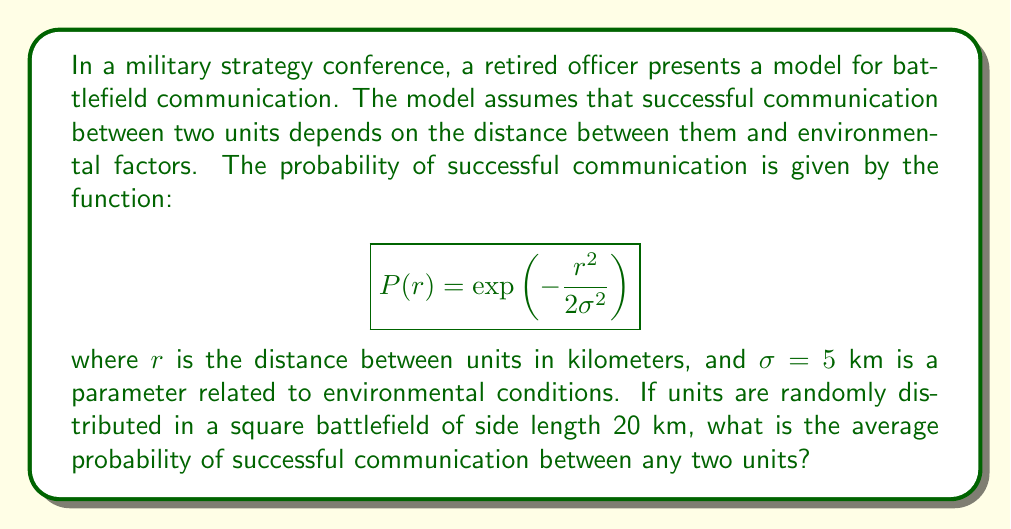Show me your answer to this math problem. To solve this problem, we need to use concepts from statistical mechanics and probability theory. Let's break it down step-by-step:

1) The probability density function for the distance between two randomly chosen points in a square is given by:

   $$f(r) = \begin{cases}
   \frac{2\pi r}{L^2} & \text{for } 0 \leq r \leq L \\
   \frac{4r}{L^2}\left(\arccos\frac{r}{L} - \frac{r}{L}\sqrt{1-\frac{r^2}{L^2}}\right) & \text{for } L < r \leq L\sqrt{2}
   \end{cases}$$

   where $L$ is the side length of the square.

2) The average probability of successful communication is the expectation value of $P(r)$ over this distribution:

   $$\langle P \rangle = \int_0^{L\sqrt{2}} P(r)f(r)dr$$

3) Substituting our expressions for $P(r)$ and $f(r)$, and using $L=20$ and $\sigma=5$:

   $$\langle P \rangle = \int_0^{20} \exp\left(-\frac{r^2}{50}\right)\frac{2\pi r}{400}dr + \int_{20}^{20\sqrt{2}} \exp\left(-\frac{r^2}{50}\right)\frac{4r}{400}\left(\arccos\frac{r}{20} - \frac{r}{20}\sqrt{1-\frac{r^2}{400}}\right)dr$$

4) This integral is complex and doesn't have a simple analytical solution. We need to evaluate it numerically.

5) Using numerical integration techniques (e.g., Simpson's rule or adaptive quadrature), we can compute the value of this integral.

6) The result of the numerical integration is approximately 0.3912.

Therefore, the average probability of successful communication between any two units is about 0.3912 or 39.12%.
Answer: 0.3912 